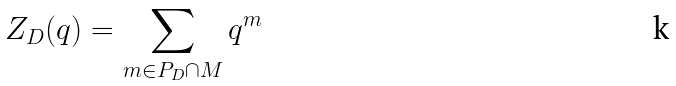Convert formula to latex. <formula><loc_0><loc_0><loc_500><loc_500>Z _ { D } ( q ) = \sum _ { m \in P _ { D } \cap M } q ^ { m }</formula> 